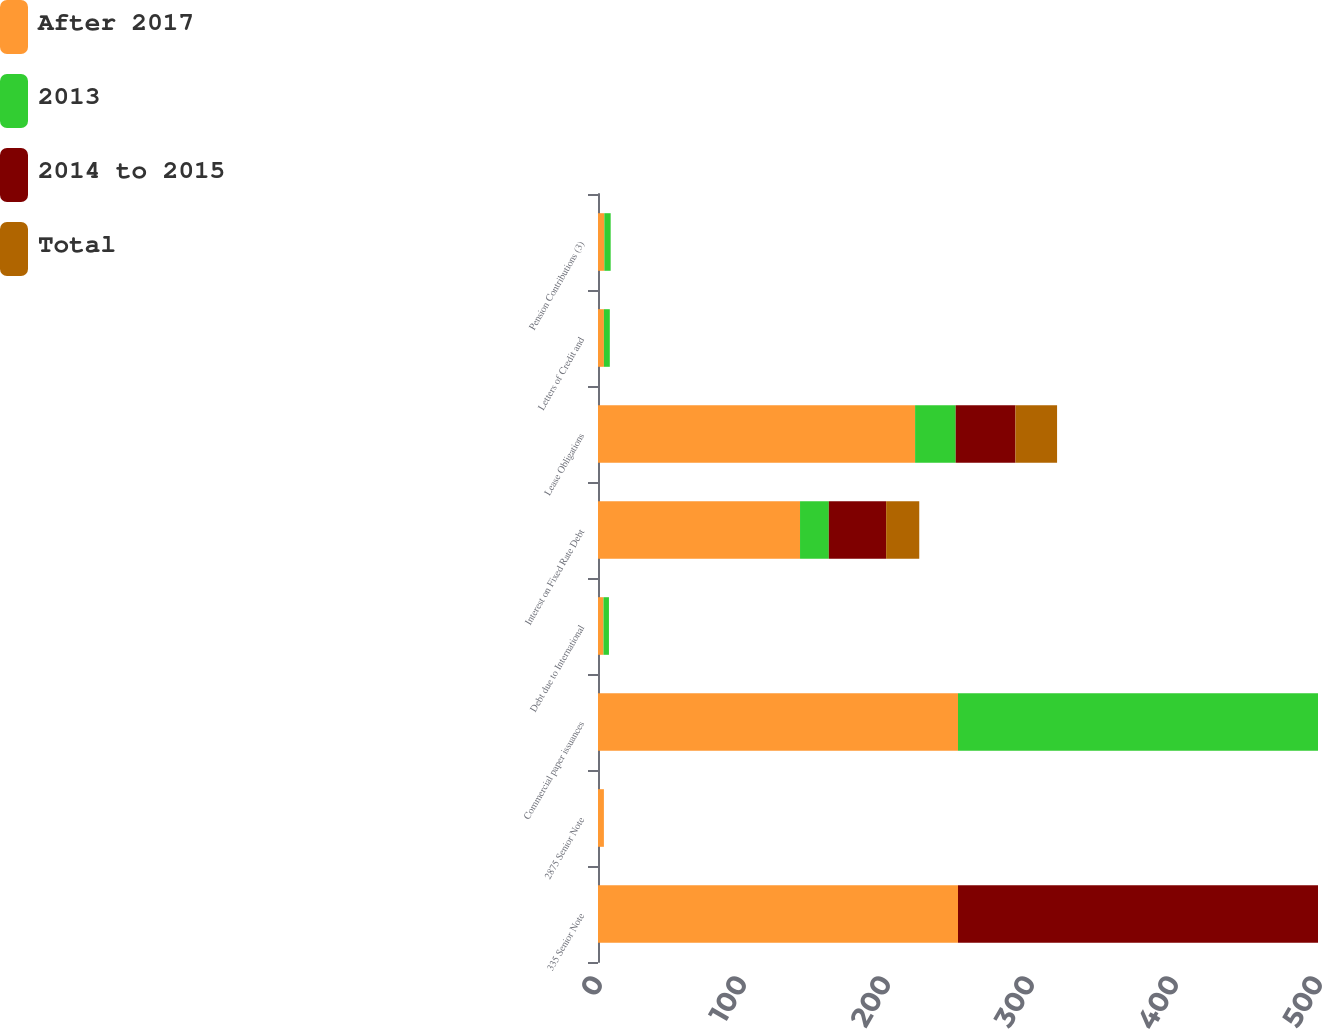Convert chart to OTSL. <chart><loc_0><loc_0><loc_500><loc_500><stacked_bar_chart><ecel><fcel>335 Senior Note<fcel>2875 Senior Note<fcel>Commercial paper issuances<fcel>Debt due to International<fcel>Interest on Fixed Rate Debt<fcel>Lease Obligations<fcel>Letters of Credit and<fcel>Pension Contributions (3)<nl><fcel>After 2017<fcel>250<fcel>4.1<fcel>250<fcel>3.8<fcel>140.3<fcel>220.2<fcel>4.1<fcel>4.4<nl><fcel>2013<fcel>0<fcel>0<fcel>250<fcel>3.8<fcel>20<fcel>28.2<fcel>4.1<fcel>4.4<nl><fcel>2014 to 2015<fcel>250<fcel>0<fcel>0<fcel>0<fcel>39.8<fcel>41.5<fcel>0<fcel>0<nl><fcel>Total<fcel>0<fcel>0<fcel>0<fcel>0<fcel>23<fcel>28.9<fcel>0<fcel>0<nl></chart> 